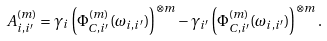Convert formula to latex. <formula><loc_0><loc_0><loc_500><loc_500>A ^ { ( m ) } _ { i , i ^ { \prime } } = \gamma _ { i } \left ( \Phi _ { C , i ^ { \prime } } ^ { ( m ) } ( \omega _ { i , i ^ { \prime } } ) \right ) ^ { \otimes m } - \gamma _ { i ^ { \prime } } \left ( \Phi _ { C , i ^ { \prime } } ^ { ( m ) } ( \omega _ { i , i ^ { \prime } } ) \right ) ^ { \otimes m } .</formula> 